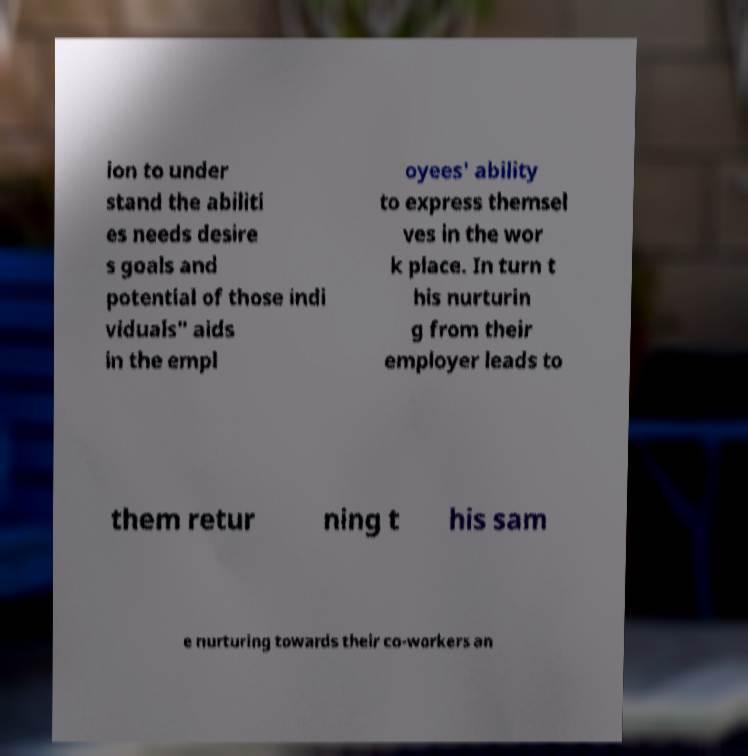There's text embedded in this image that I need extracted. Can you transcribe it verbatim? ion to under stand the abiliti es needs desire s goals and potential of those indi viduals" aids in the empl oyees' ability to express themsel ves in the wor k place. In turn t his nurturin g from their employer leads to them retur ning t his sam e nurturing towards their co-workers an 